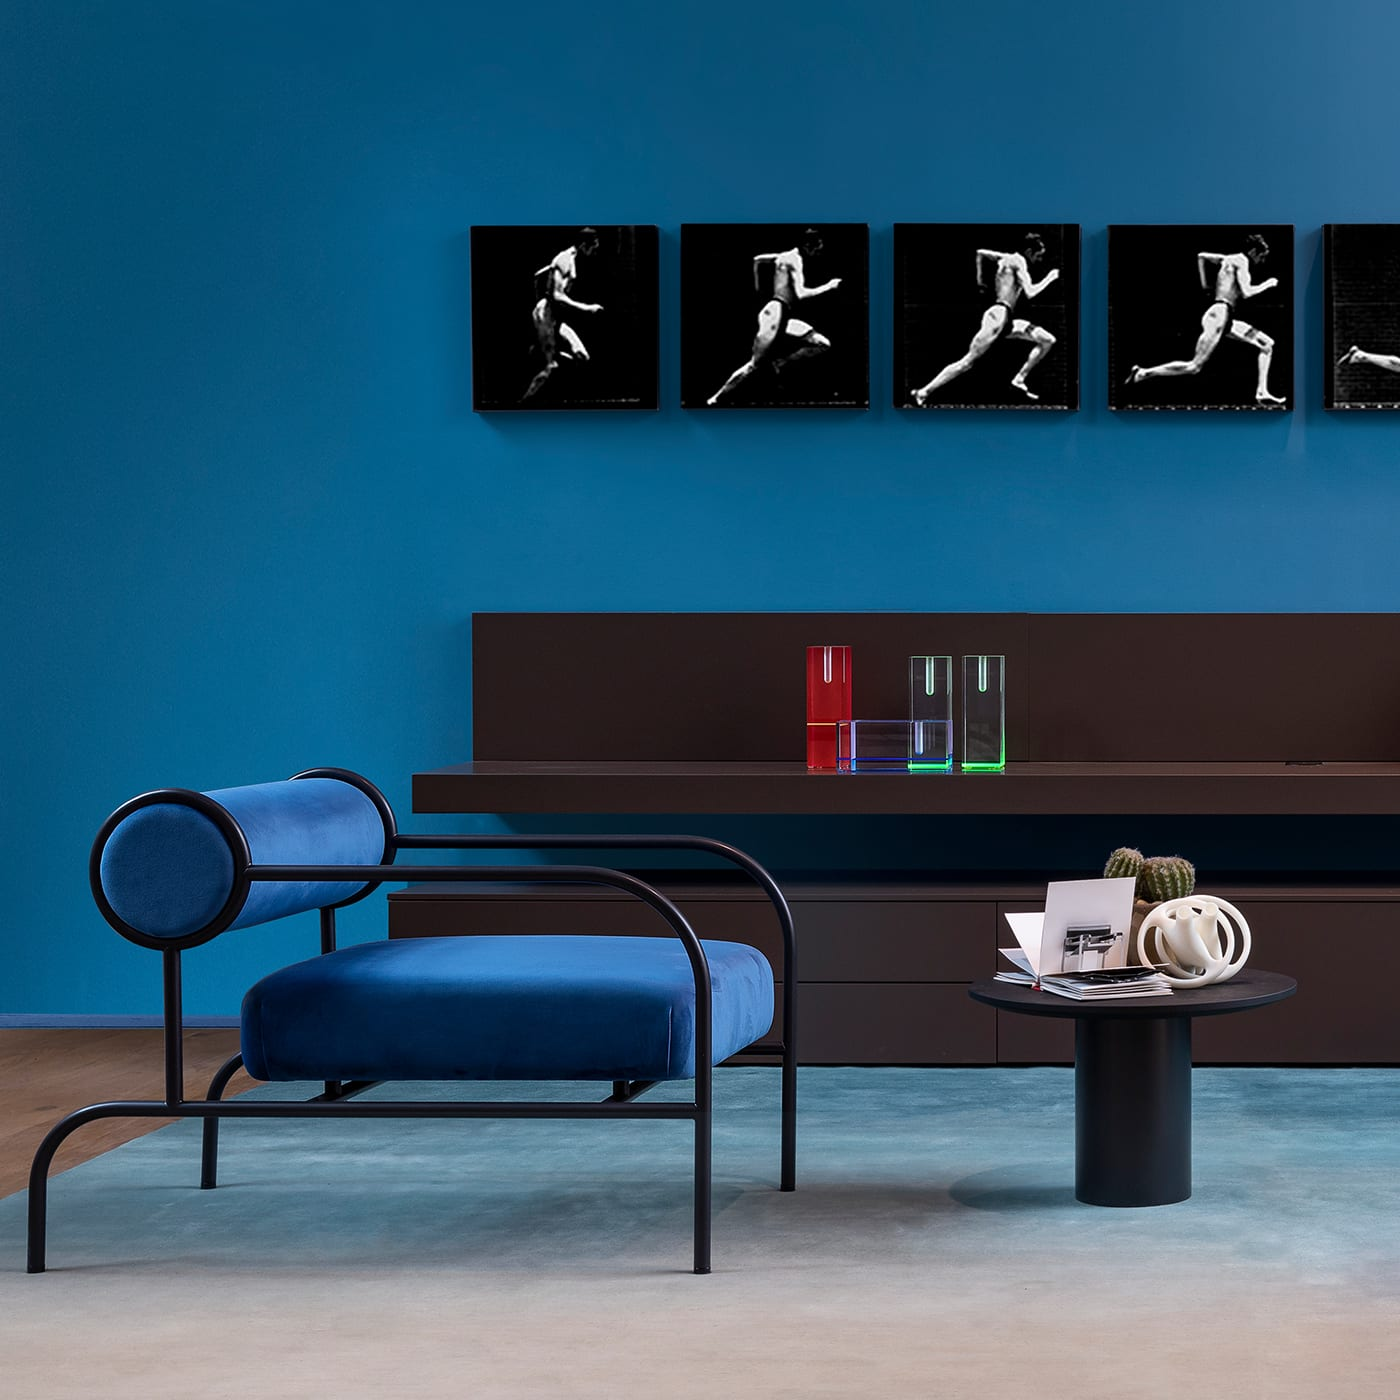Please describe any decor items visible in this image apart from the furniture. Aside from the furniture, the decor includes a set of colorful glass vases in red, green, and blue hues on a brown shelf, as well as a series of black-and-white photographic prints of dancers displayed on the wall, adding an artistic touch to the space. 